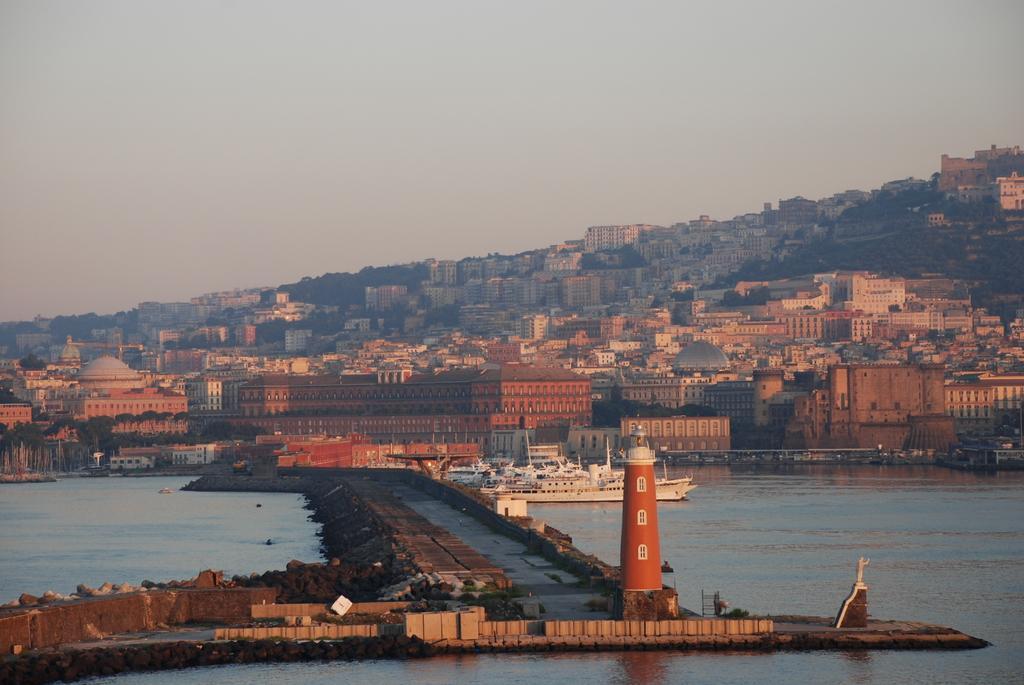Please provide a concise description of this image. In this image there is a lighthouse surrounded by water and the background is the sky. 